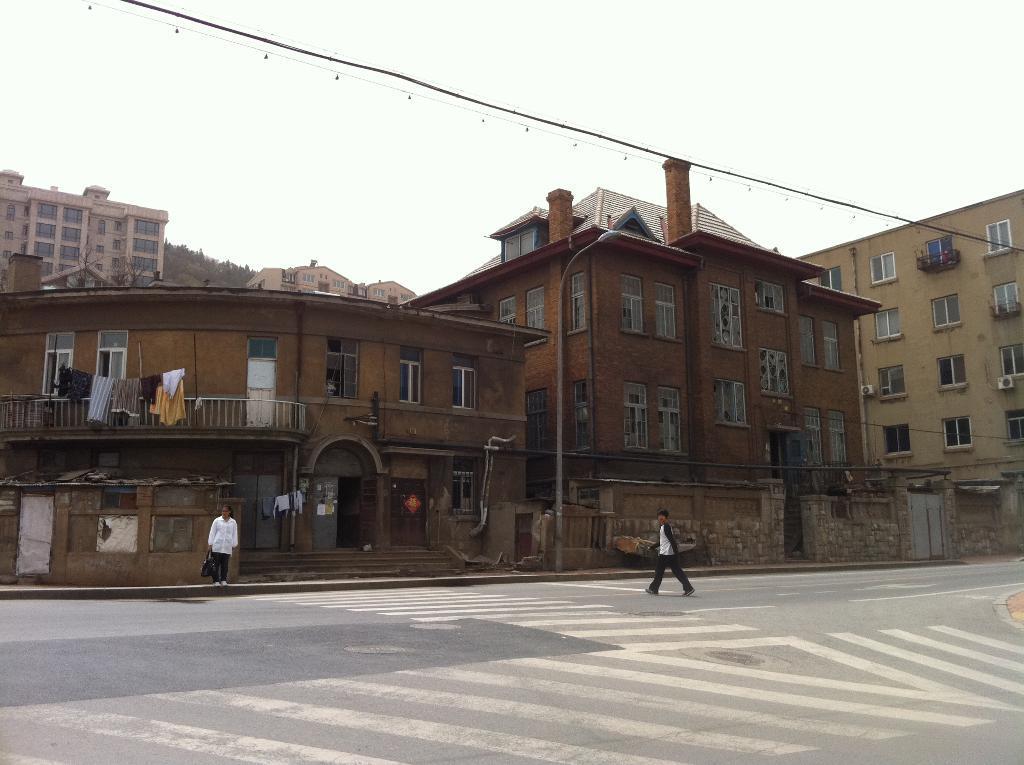Describe this image in one or two sentences. In this picture I can observe a person walking on the road. On the left side I can observe another person. Behind the person I can observe buildings. In the background I can observe sky. 